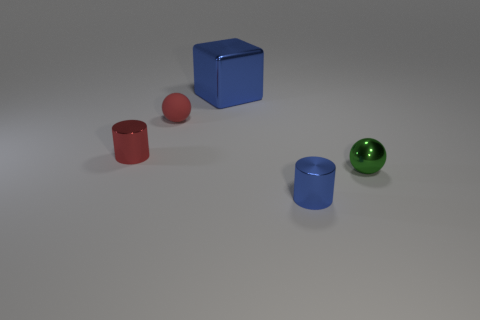Add 2 tiny red matte balls. How many objects exist? 7 Subtract all blocks. How many objects are left? 4 Add 1 red shiny objects. How many red shiny objects exist? 2 Subtract 0 cyan cylinders. How many objects are left? 5 Subtract all small red cylinders. Subtract all small blue rubber cubes. How many objects are left? 4 Add 3 blue blocks. How many blue blocks are left? 4 